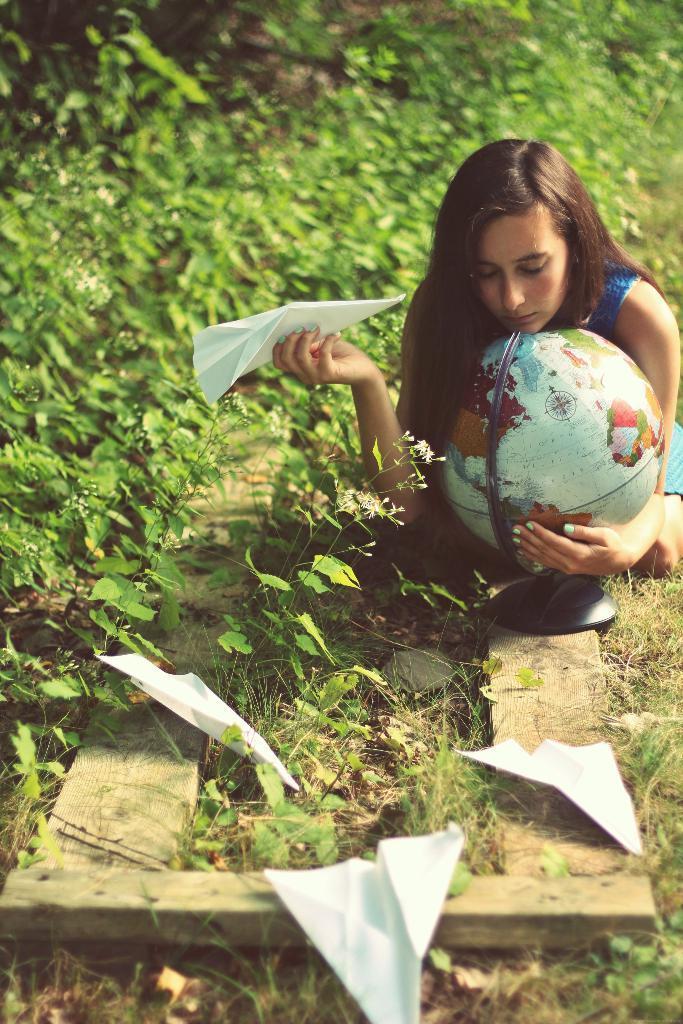Describe this image in one or two sentences. There is a woman holding a globe and paper. We can see papers on wooden planks, plants and flowers. 